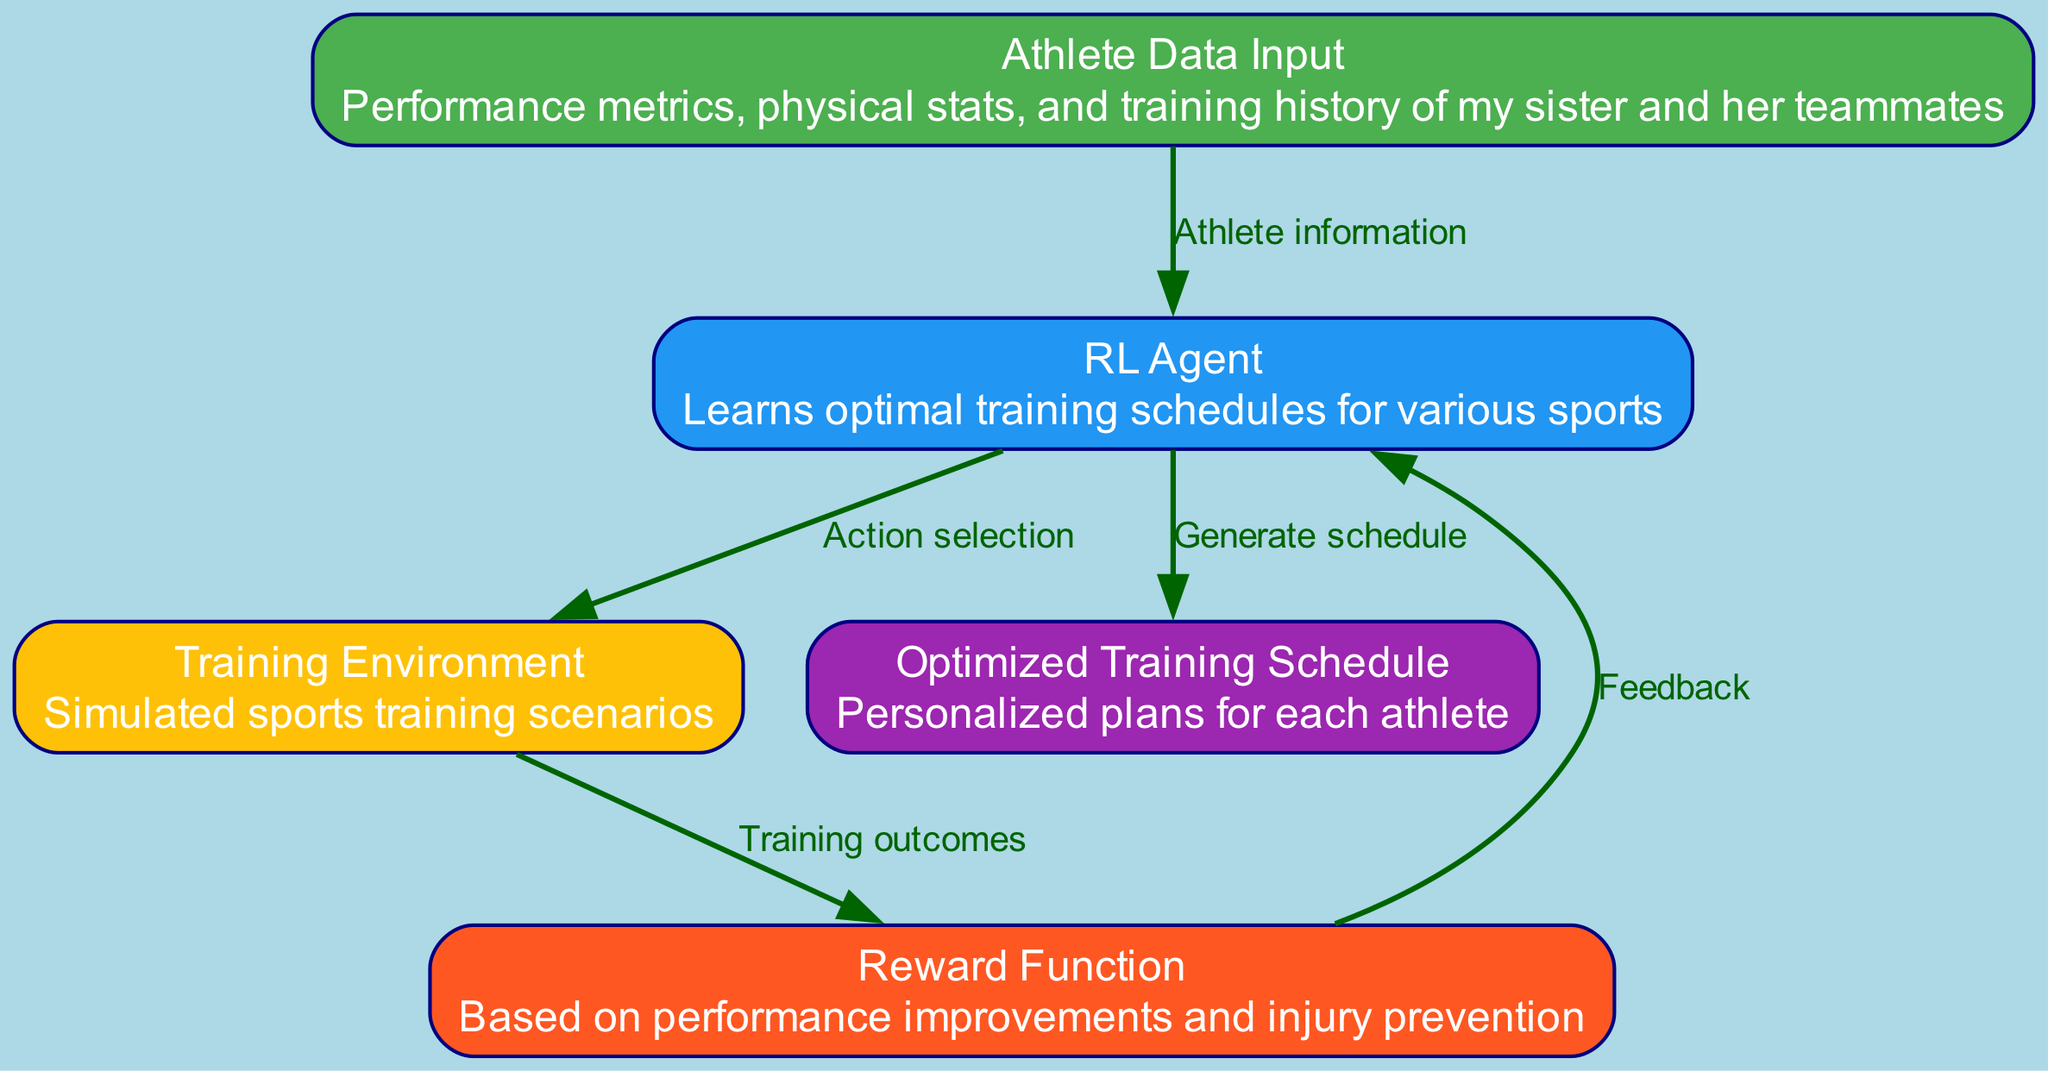What are the input data types for the RL agent? The input data types for the RL agent are performance metrics, physical stats, and training history of my sister and her teammates. This information is specified in the "Athlete Data Input" node.
Answer: Performance metrics, physical stats, and training history How many nodes are present in the diagram? The diagram contains a total of five nodes: Athlete Data Input, RL Agent, Training Environment, Reward Function, and Optimized Training Schedule. Counting each of these gives a total of five nodes.
Answer: 5 What action does the RL agent perform towards the environment? The RL agent performs action selection towards the Training Environment. This relationship is indicated by the directed edge connecting the RL Agent to the Training Environment with the label "Action selection."
Answer: Action selection What type of outcomes does the training environment provide to the reward function? The training environment provides training outcomes to the reward function. This is shown by the edge that connects the Training Environment to the Reward Function, labeled "Training outcomes."
Answer: Training outcomes What kind of feedback does the reward function give to the RL agent? The reward function provides feedback based on performance improvements and injury prevention to the RL agent. This is indicated by the directed edge from the Reward Function back to the RL Agent, labeled "Feedback."
Answer: Feedback What does the output node represent in the diagram? The output node represents optimized training schedules as personalized plans for each athlete. This information is described in the "Optimized Training Schedule" node.
Answer: Optimized Training Schedule Which node is responsible for generating the training schedule? The RL agent is responsible for generating the training schedule according to the diagram. This action is depicted by the directed edge from the RL Agent to the output node labeled "Generate schedule."
Answer: RL Agent What is the purpose of the reward function in this system? The purpose of the reward function is to evaluate the actions of the RL agent based on performance improvements and injury prevention, guiding the learning process. This is indicated in the explanation of the Reward Function node.
Answer: Evaluation of actions How does the RL agent receive information from the athlete data input node? The RL agent receives information from the athlete data input node through an edge that is labeled "Athlete information," indicating that it directly takes this data as input for learning.
Answer: Athlete information 